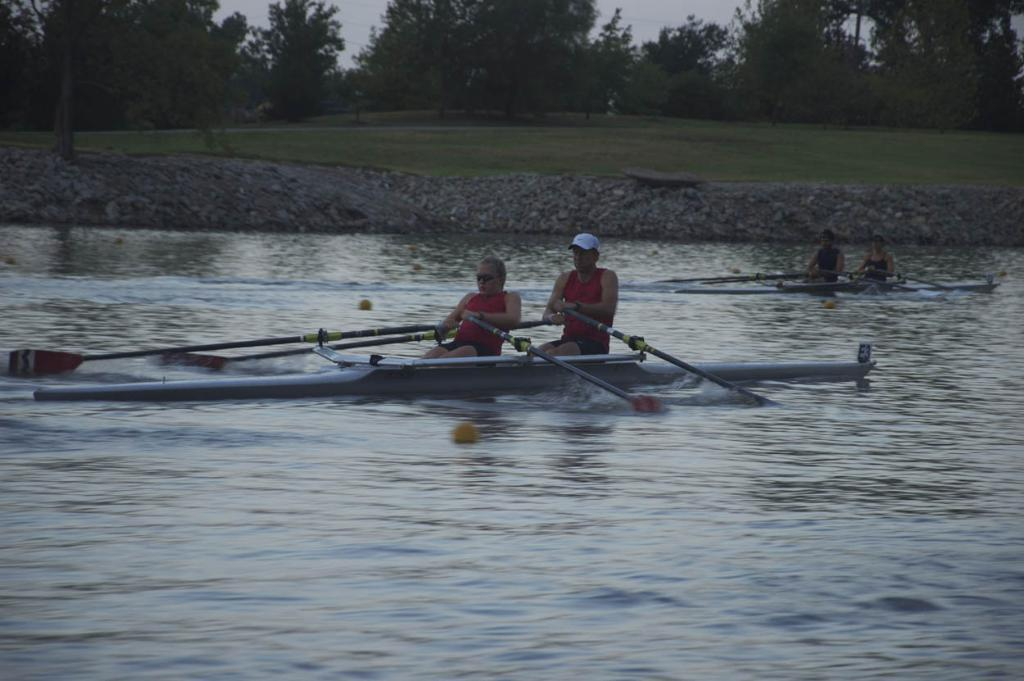How many people are in the image? There are four persons in the image. What are the persons doing in the image? The persons are riding boats. Where are the boats located? The boats are on the water. What are the persons using to propel the boats? The persons are holding paddles. What can be seen in the background of the image? There is grass, trees, and the sky visible in the background of the image. What type of duck can be seen swimming with the persons in the image? There are no ducks present in the image; the persons are riding boats on the water. What achievement did the persons accomplish during their recess in the image? There is no indication of a recess or any achievements in the image; the persons are simply riding boats on the water. 